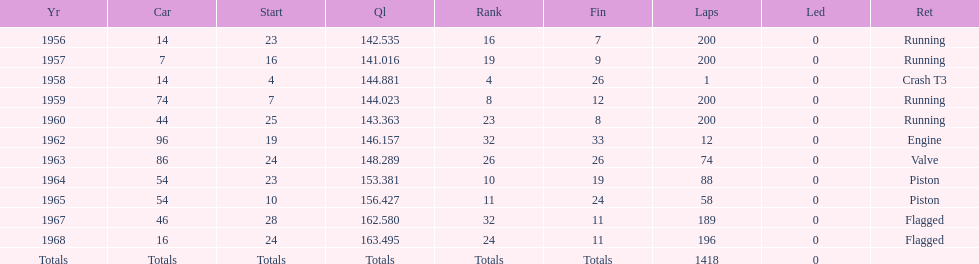How long did bob veith have the number 54 car at the indy 500? 2 years. 